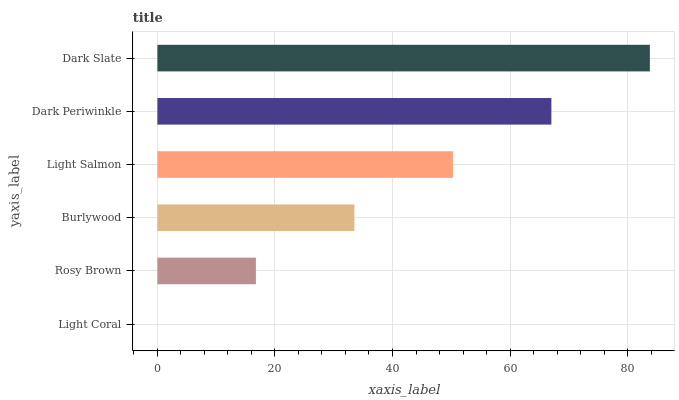Is Light Coral the minimum?
Answer yes or no. Yes. Is Dark Slate the maximum?
Answer yes or no. Yes. Is Rosy Brown the minimum?
Answer yes or no. No. Is Rosy Brown the maximum?
Answer yes or no. No. Is Rosy Brown greater than Light Coral?
Answer yes or no. Yes. Is Light Coral less than Rosy Brown?
Answer yes or no. Yes. Is Light Coral greater than Rosy Brown?
Answer yes or no. No. Is Rosy Brown less than Light Coral?
Answer yes or no. No. Is Light Salmon the high median?
Answer yes or no. Yes. Is Burlywood the low median?
Answer yes or no. Yes. Is Dark Periwinkle the high median?
Answer yes or no. No. Is Dark Periwinkle the low median?
Answer yes or no. No. 